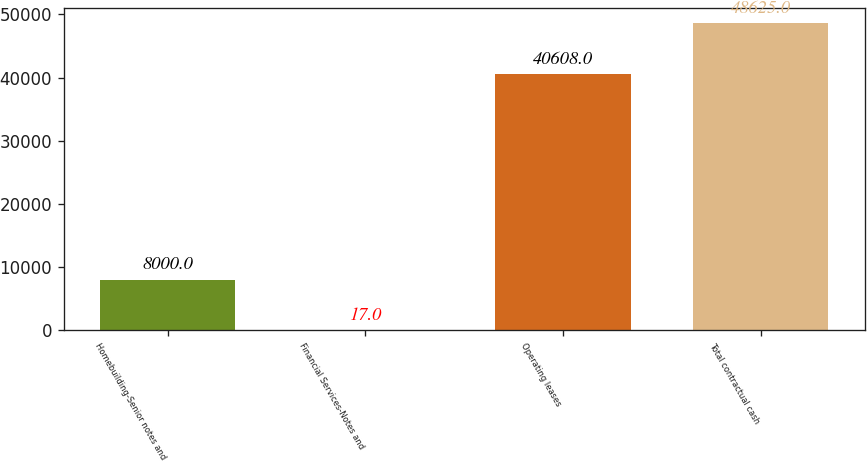Convert chart. <chart><loc_0><loc_0><loc_500><loc_500><bar_chart><fcel>Homebuilding-Senior notes and<fcel>Financial Services-Notes and<fcel>Operating leases<fcel>Total contractual cash<nl><fcel>8000<fcel>17<fcel>40608<fcel>48625<nl></chart> 